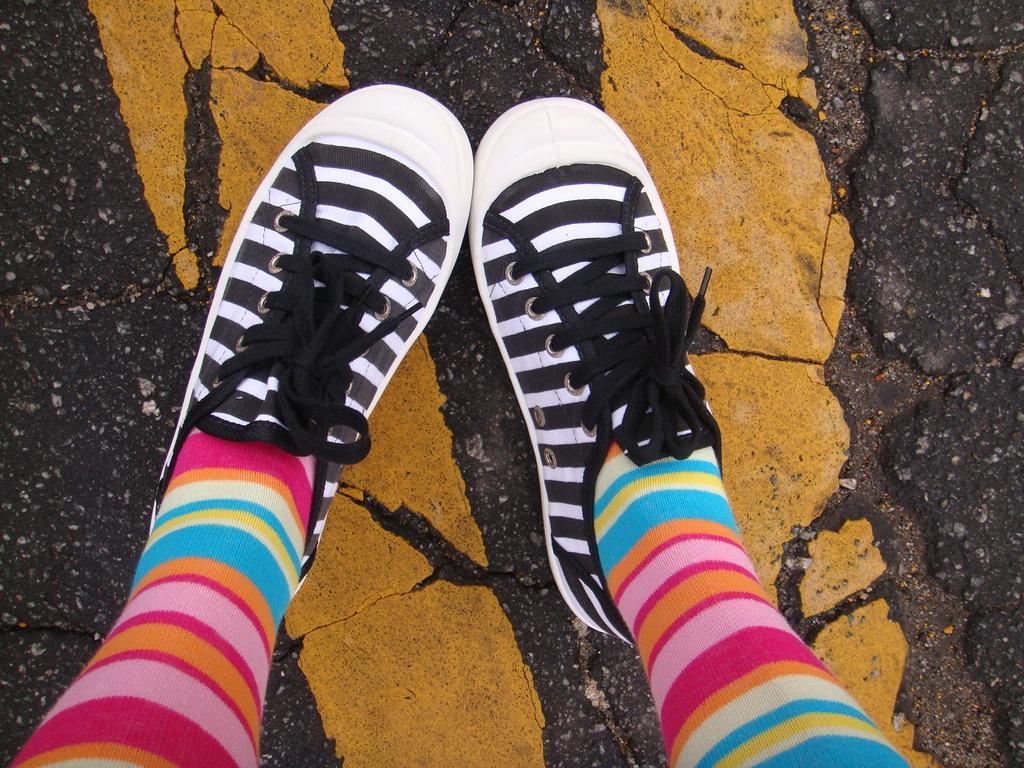Can you describe this image briefly? Here we can see legs of a person wore shoes and this is a road. 